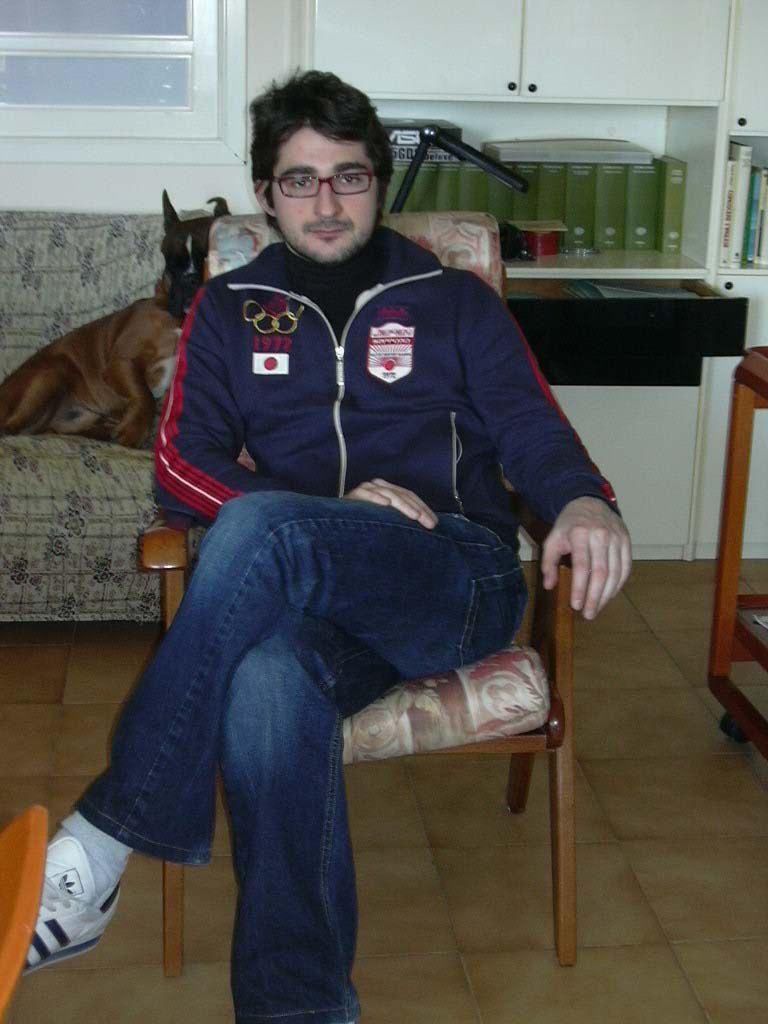How would you summarize this image in a sentence or two? There is a man sitting on the chair and he has spectacles. This is floor. There is a dog on the sofa. In the background we can see cupboards, books, and a window. 